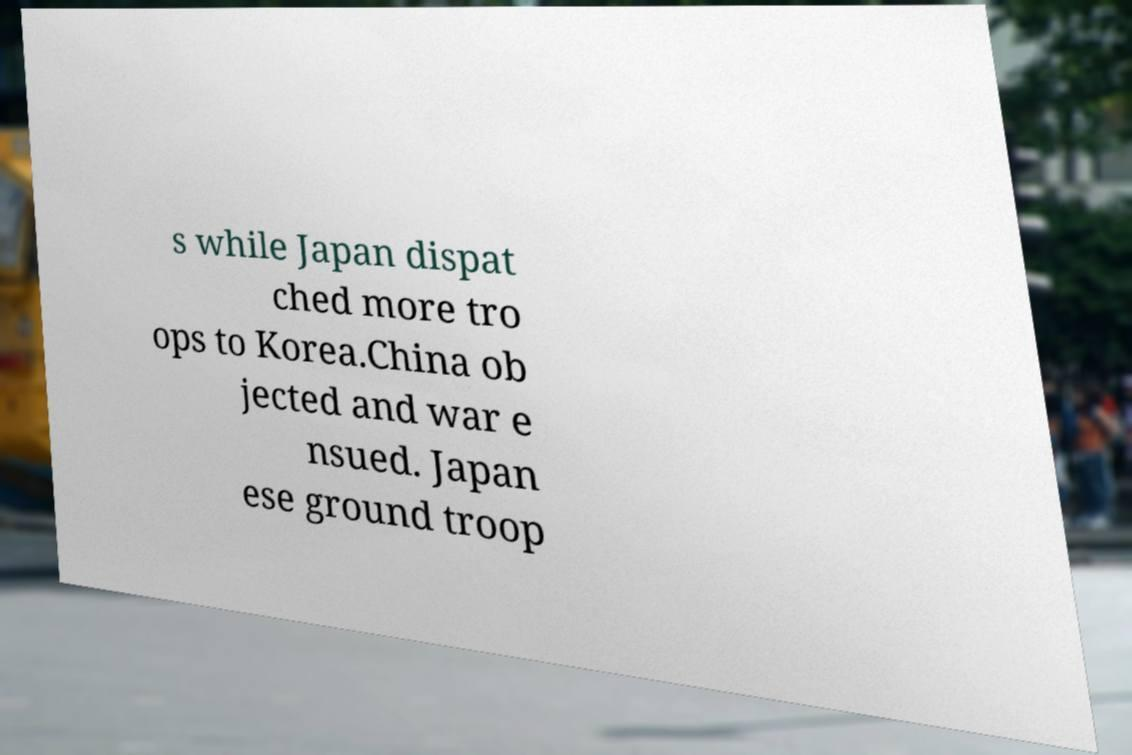Please identify and transcribe the text found in this image. s while Japan dispat ched more tro ops to Korea.China ob jected and war e nsued. Japan ese ground troop 